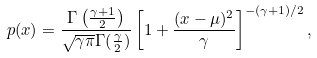<formula> <loc_0><loc_0><loc_500><loc_500>p ( x ) = \frac { \Gamma \left ( \frac { \gamma + 1 } { 2 } \right ) } { \sqrt { \gamma \pi } \Gamma ( \frac { \gamma } { 2 } ) } \left [ 1 + \frac { ( x - \mu ) ^ { 2 } } { \gamma } \right ] ^ { - ( \gamma + 1 ) / 2 } ,</formula> 